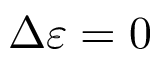<formula> <loc_0><loc_0><loc_500><loc_500>\Delta \varepsilon = 0</formula> 